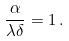Convert formula to latex. <formula><loc_0><loc_0><loc_500><loc_500>\frac { \alpha } { \lambda \delta } = 1 \, .</formula> 